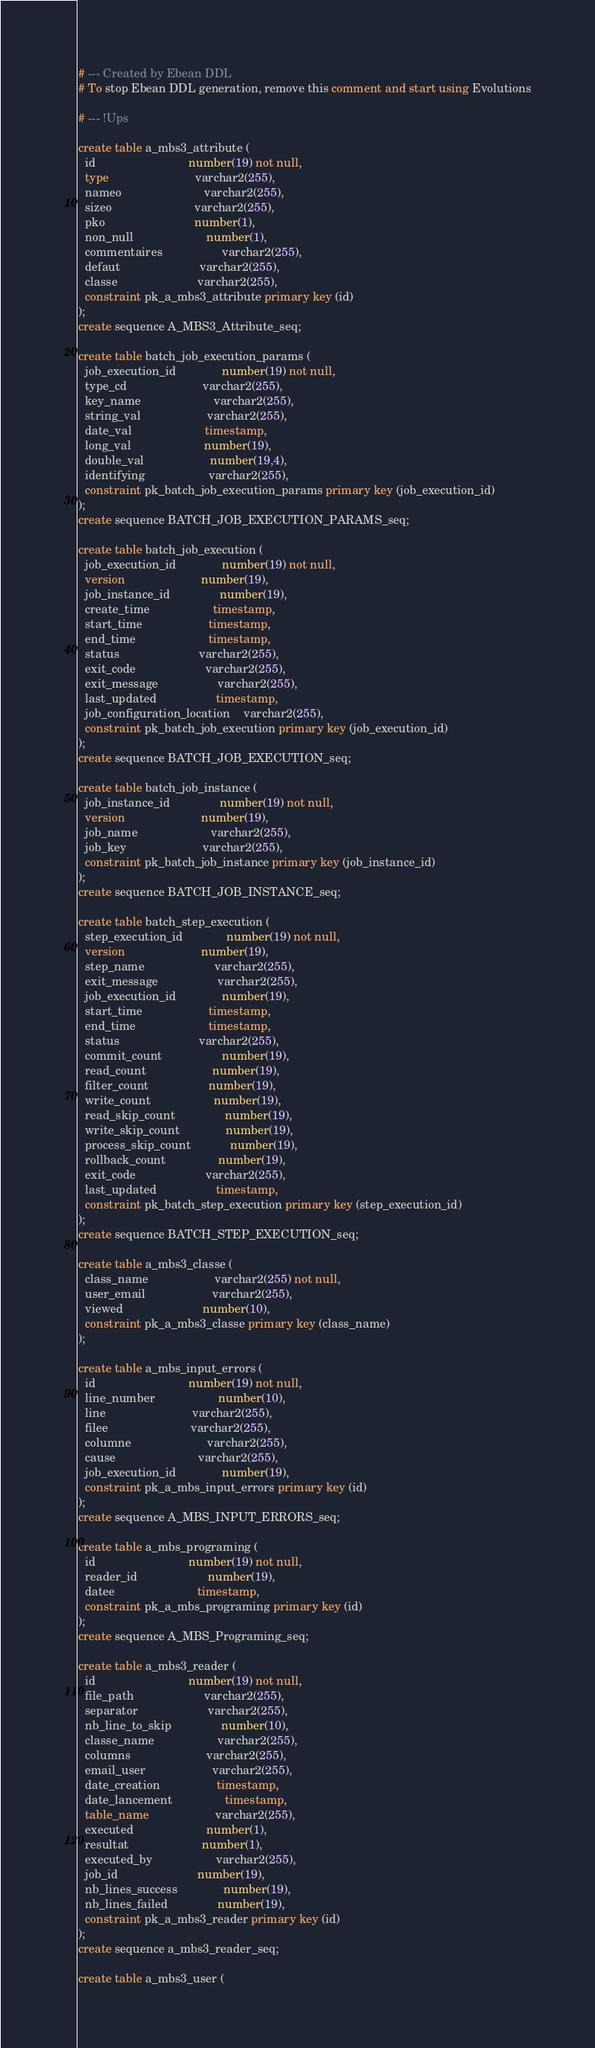Convert code to text. <code><loc_0><loc_0><loc_500><loc_500><_SQL_># --- Created by Ebean DDL
# To stop Ebean DDL generation, remove this comment and start using Evolutions

# --- !Ups

create table a_mbs3_attribute (
  id                            number(19) not null,
  type                          varchar2(255),
  nameo                         varchar2(255),
  sizeo                         varchar2(255),
  pko                           number(1),
  non_null                      number(1),
  commentaires                  varchar2(255),
  defaut                        varchar2(255),
  classe                        varchar2(255),
  constraint pk_a_mbs3_attribute primary key (id)
);
create sequence A_MBS3_Attribute_seq;

create table batch_job_execution_params (
  job_execution_id              number(19) not null,
  type_cd                       varchar2(255),
  key_name                      varchar2(255),
  string_val                    varchar2(255),
  date_val                      timestamp,
  long_val                      number(19),
  double_val                    number(19,4),
  identifying                   varchar2(255),
  constraint pk_batch_job_execution_params primary key (job_execution_id)
);
create sequence BATCH_JOB_EXECUTION_PARAMS_seq;

create table batch_job_execution (
  job_execution_id              number(19) not null,
  version                       number(19),
  job_instance_id               number(19),
  create_time                   timestamp,
  start_time                    timestamp,
  end_time                      timestamp,
  status                        varchar2(255),
  exit_code                     varchar2(255),
  exit_message                  varchar2(255),
  last_updated                  timestamp,
  job_configuration_location    varchar2(255),
  constraint pk_batch_job_execution primary key (job_execution_id)
);
create sequence BATCH_JOB_EXECUTION_seq;

create table batch_job_instance (
  job_instance_id               number(19) not null,
  version                       number(19),
  job_name                      varchar2(255),
  job_key                       varchar2(255),
  constraint pk_batch_job_instance primary key (job_instance_id)
);
create sequence BATCH_JOB_INSTANCE_seq;

create table batch_step_execution (
  step_execution_id             number(19) not null,
  version                       number(19),
  step_name                     varchar2(255),
  exit_message                  varchar2(255),
  job_execution_id              number(19),
  start_time                    timestamp,
  end_time                      timestamp,
  status                        varchar2(255),
  commit_count                  number(19),
  read_count                    number(19),
  filter_count                  number(19),
  write_count                   number(19),
  read_skip_count               number(19),
  write_skip_count              number(19),
  process_skip_count            number(19),
  rollback_count                number(19),
  exit_code                     varchar2(255),
  last_updated                  timestamp,
  constraint pk_batch_step_execution primary key (step_execution_id)
);
create sequence BATCH_STEP_EXECUTION_seq;

create table a_mbs3_classe (
  class_name                    varchar2(255) not null,
  user_email                    varchar2(255),
  viewed                        number(10),
  constraint pk_a_mbs3_classe primary key (class_name)
);

create table a_mbs_input_errors (
  id                            number(19) not null,
  line_number                   number(10),
  line                          varchar2(255),
  filee                         varchar2(255),
  columne                       varchar2(255),
  cause                         varchar2(255),
  job_execution_id              number(19),
  constraint pk_a_mbs_input_errors primary key (id)
);
create sequence A_MBS_INPUT_ERRORS_seq;

create table a_mbs_programing (
  id                            number(19) not null,
  reader_id                     number(19),
  datee                         timestamp,
  constraint pk_a_mbs_programing primary key (id)
);
create sequence A_MBS_Programing_seq;

create table a_mbs3_reader (
  id                            number(19) not null,
  file_path                     varchar2(255),
  separator                     varchar2(255),
  nb_line_to_skip               number(10),
  classe_name                   varchar2(255),
  columns                       varchar2(255),
  email_user                    varchar2(255),
  date_creation                 timestamp,
  date_lancement                timestamp,
  table_name                    varchar2(255),
  executed                      number(1),
  resultat                      number(1),
  executed_by                   varchar2(255),
  job_id                        number(19),
  nb_lines_success              number(19),
  nb_lines_failed               number(19),
  constraint pk_a_mbs3_reader primary key (id)
);
create sequence a_mbs3_reader_seq;

create table a_mbs3_user (</code> 